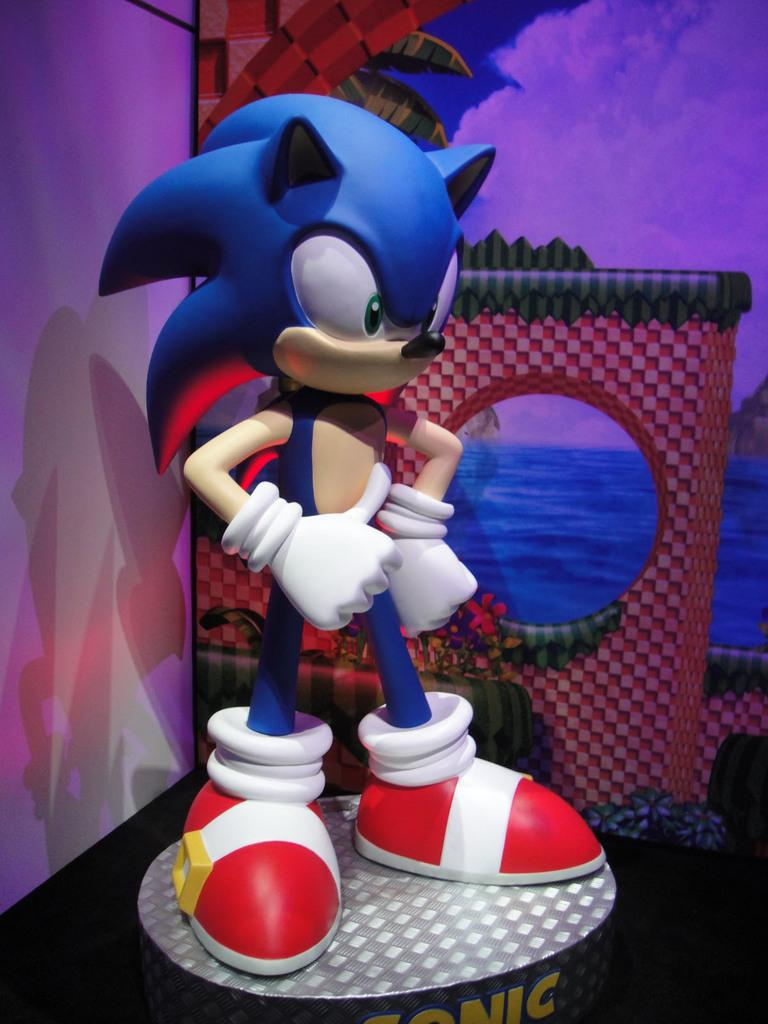What object is placed on a platform in the image? There is a toy on a platform in the image. What can be seen in the background of the image? There is a wall, a painting of leaves, water, and the sky with clouds visible in the background. What time of day is it in the image, based on the behavior of the animal? There is no animal present in the image, so it is not possible to determine the time of day based on its behavior. 